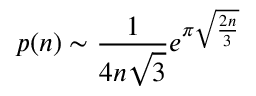Convert formula to latex. <formula><loc_0><loc_0><loc_500><loc_500>p ( n ) \sim { \frac { 1 } { 4 n { \sqrt { 3 } } } } e ^ { \pi { \sqrt { \frac { 2 n } { 3 } } } }</formula> 